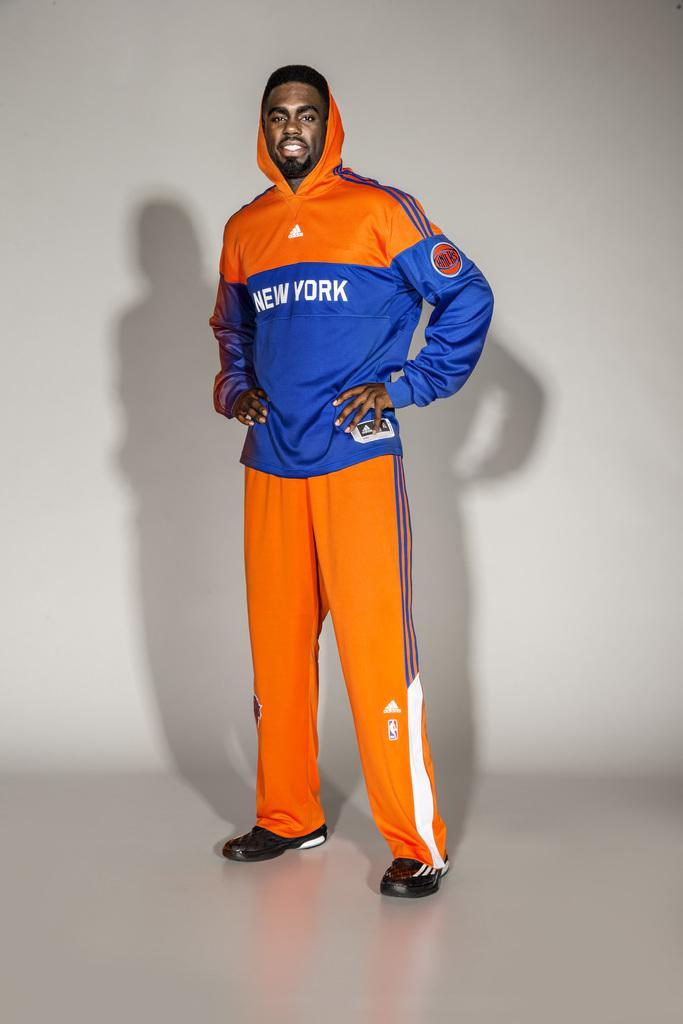<image>
Share a concise interpretation of the image provided. A man wearing an orange track suit that says New York is standing on a white background with his hands on his hips. 